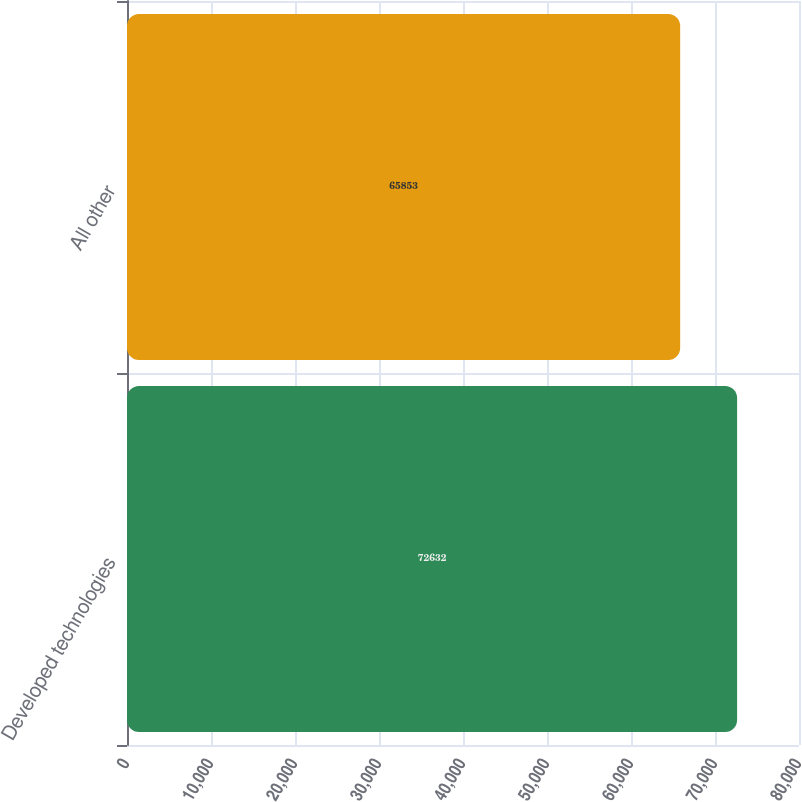Convert chart to OTSL. <chart><loc_0><loc_0><loc_500><loc_500><bar_chart><fcel>Developed technologies<fcel>All other<nl><fcel>72632<fcel>65853<nl></chart> 